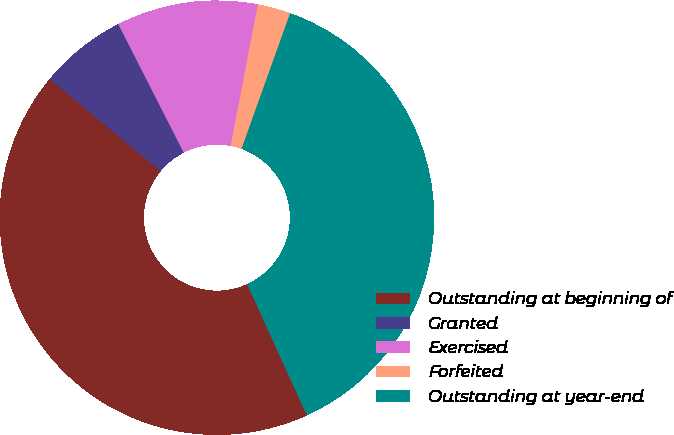<chart> <loc_0><loc_0><loc_500><loc_500><pie_chart><fcel>Outstanding at beginning of<fcel>Granted<fcel>Exercised<fcel>Forfeited<fcel>Outstanding at year-end<nl><fcel>42.81%<fcel>6.49%<fcel>10.52%<fcel>2.45%<fcel>37.72%<nl></chart> 